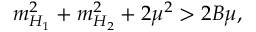<formula> <loc_0><loc_0><loc_500><loc_500>m _ { H _ { 1 } } ^ { 2 } + m _ { H _ { 2 } } ^ { 2 } + 2 \mu ^ { 2 } > 2 B \mu ,</formula> 